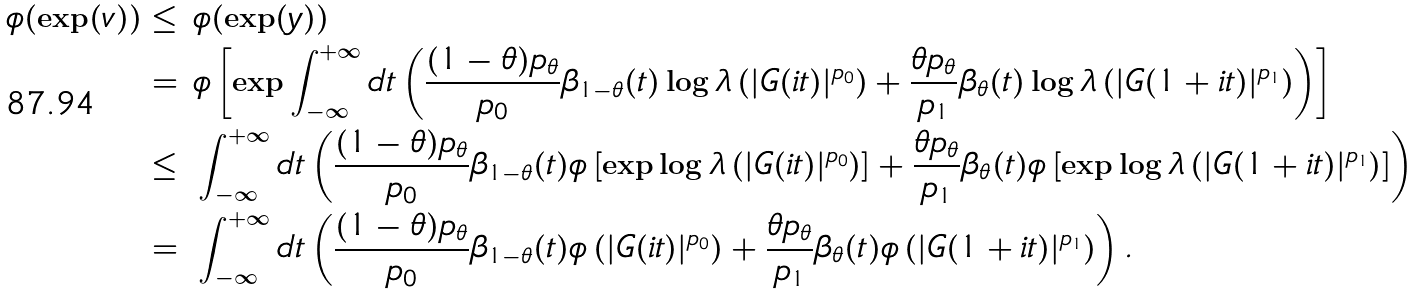Convert formula to latex. <formula><loc_0><loc_0><loc_500><loc_500>\phi ( \exp ( v ) ) \leq & \ \phi ( \exp ( y ) ) \\ = & \ \phi \left [ \exp \int _ { - \infty } ^ { + \infty } d t \left ( \frac { ( 1 - \theta ) p _ { \theta } } { p _ { 0 } } \beta _ { 1 - \theta } ( t ) \log \lambda \left ( | G ( i t ) | ^ { p _ { 0 } } \right ) + \frac { \theta p _ { \theta } } { p _ { 1 } } \beta _ { \theta } ( t ) \log \lambda \left ( | G ( 1 + i t ) | ^ { p _ { 1 } } \right ) \right ) \right ] \\ \leq & \ \int _ { - \infty } ^ { + \infty } d t \left ( \frac { ( 1 - \theta ) p _ { \theta } } { p _ { 0 } } \beta _ { 1 - \theta } ( t ) \phi \left [ \exp \log \lambda \left ( | G ( i t ) | ^ { p _ { 0 } } \right ) \right ] + \frac { \theta p _ { \theta } } { p _ { 1 } } \beta _ { \theta } ( t ) \phi \left [ \exp \log \lambda \left ( | G ( 1 + i t ) | ^ { p _ { 1 } } \right ) \right ] \right ) \\ = & \ \int _ { - \infty } ^ { + \infty } d t \left ( \frac { ( 1 - \theta ) p _ { \theta } } { p _ { 0 } } \beta _ { 1 - \theta } ( t ) \phi \left ( | G ( i t ) | ^ { p _ { 0 } } \right ) + \frac { \theta p _ { \theta } } { p _ { 1 } } \beta _ { \theta } ( t ) \phi \left ( | G ( 1 + i t ) | ^ { p _ { 1 } } \right ) \right ) .</formula> 